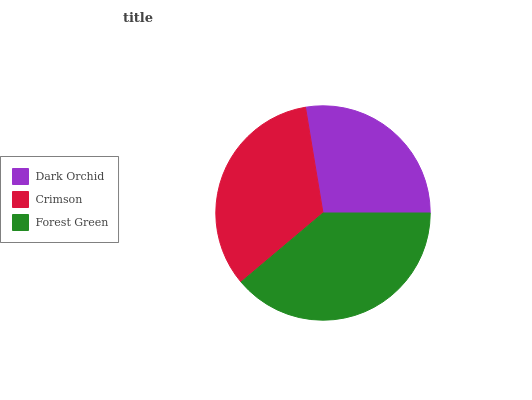Is Dark Orchid the minimum?
Answer yes or no. Yes. Is Forest Green the maximum?
Answer yes or no. Yes. Is Crimson the minimum?
Answer yes or no. No. Is Crimson the maximum?
Answer yes or no. No. Is Crimson greater than Dark Orchid?
Answer yes or no. Yes. Is Dark Orchid less than Crimson?
Answer yes or no. Yes. Is Dark Orchid greater than Crimson?
Answer yes or no. No. Is Crimson less than Dark Orchid?
Answer yes or no. No. Is Crimson the high median?
Answer yes or no. Yes. Is Crimson the low median?
Answer yes or no. Yes. Is Forest Green the high median?
Answer yes or no. No. Is Dark Orchid the low median?
Answer yes or no. No. 